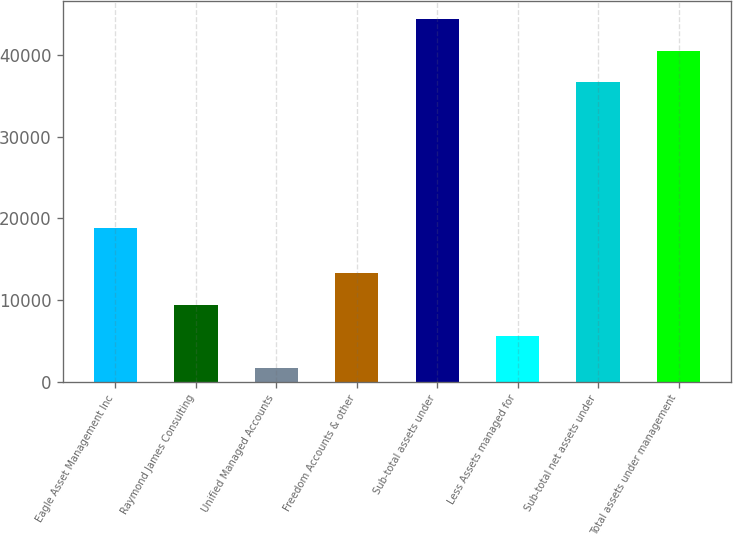<chart> <loc_0><loc_0><loc_500><loc_500><bar_chart><fcel>Eagle Asset Management Inc<fcel>Raymond James Consulting<fcel>Unified Managed Accounts<fcel>Freedom Accounts & other<fcel>Sub-total assets under<fcel>Less Assets managed for<fcel>Sub-total net assets under<fcel>Total assets under management<nl><fcel>18745<fcel>9380.6<fcel>1653<fcel>13244.4<fcel>44350.6<fcel>5516.8<fcel>36623<fcel>40486.8<nl></chart> 